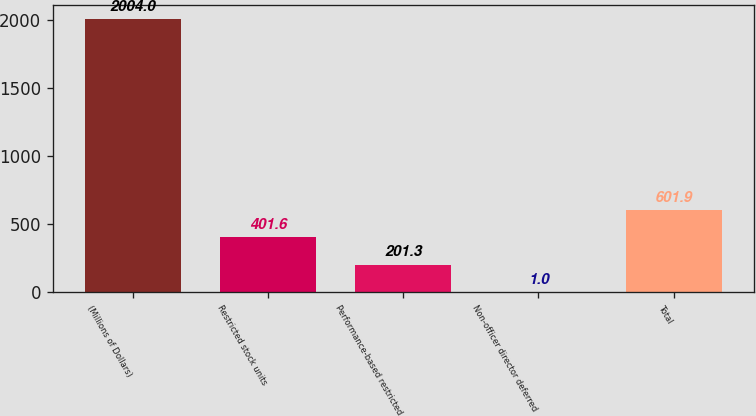Convert chart. <chart><loc_0><loc_0><loc_500><loc_500><bar_chart><fcel>(Millions of Dollars)<fcel>Restricted stock units<fcel>Performance-based restricted<fcel>Non-officer director deferred<fcel>Total<nl><fcel>2004<fcel>401.6<fcel>201.3<fcel>1<fcel>601.9<nl></chart> 